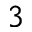Convert formula to latex. <formula><loc_0><loc_0><loc_500><loc_500>^ { 3 }</formula> 